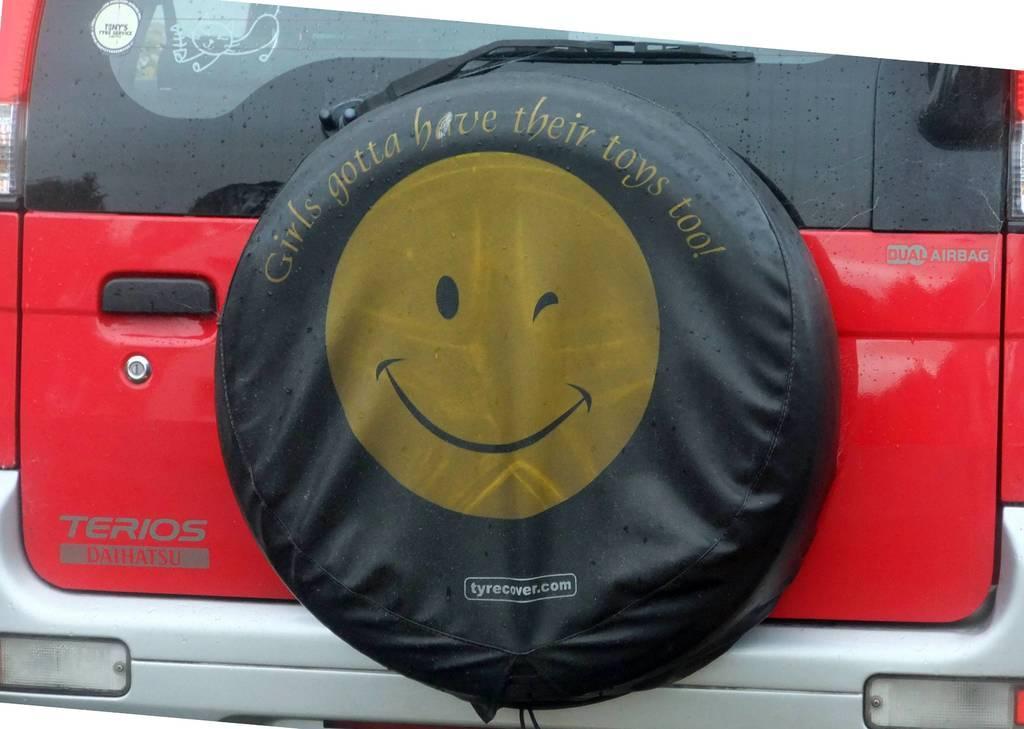How would you summarize this image in a sentence or two? In this picture I can see there is a red color car and there is a circular object placed here and there is a symbol on it. The door has a handle and there is a glass wiper. 